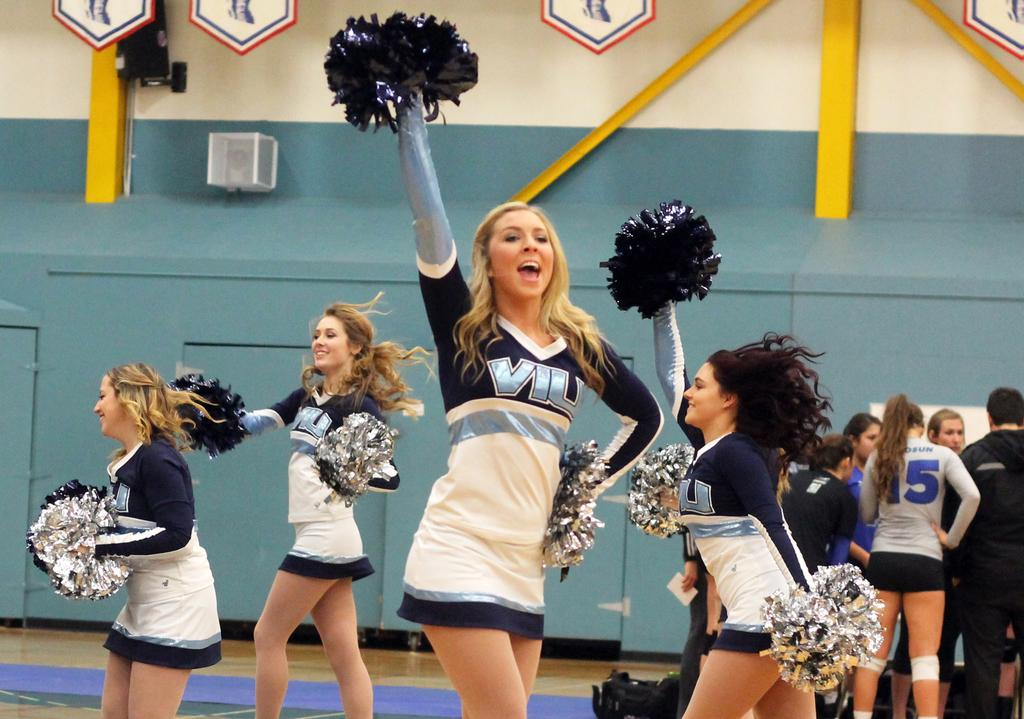<image>
Present a compact description of the photo's key features. Four cheerleaders from VIU are waving pompoms and shouting. 